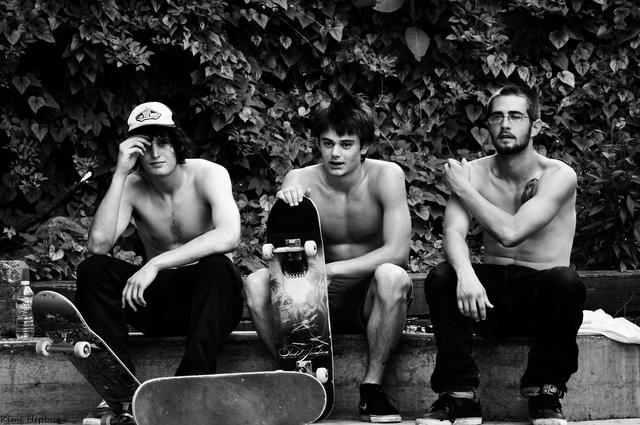Are the men wearing shirts?
Concise answer only. No. Are any of the men wearing a hat?
Keep it brief. Yes. How many people in this photo are wearing glasses?
Quick response, please. 1. Are the men in a park?
Keep it brief. Yes. 